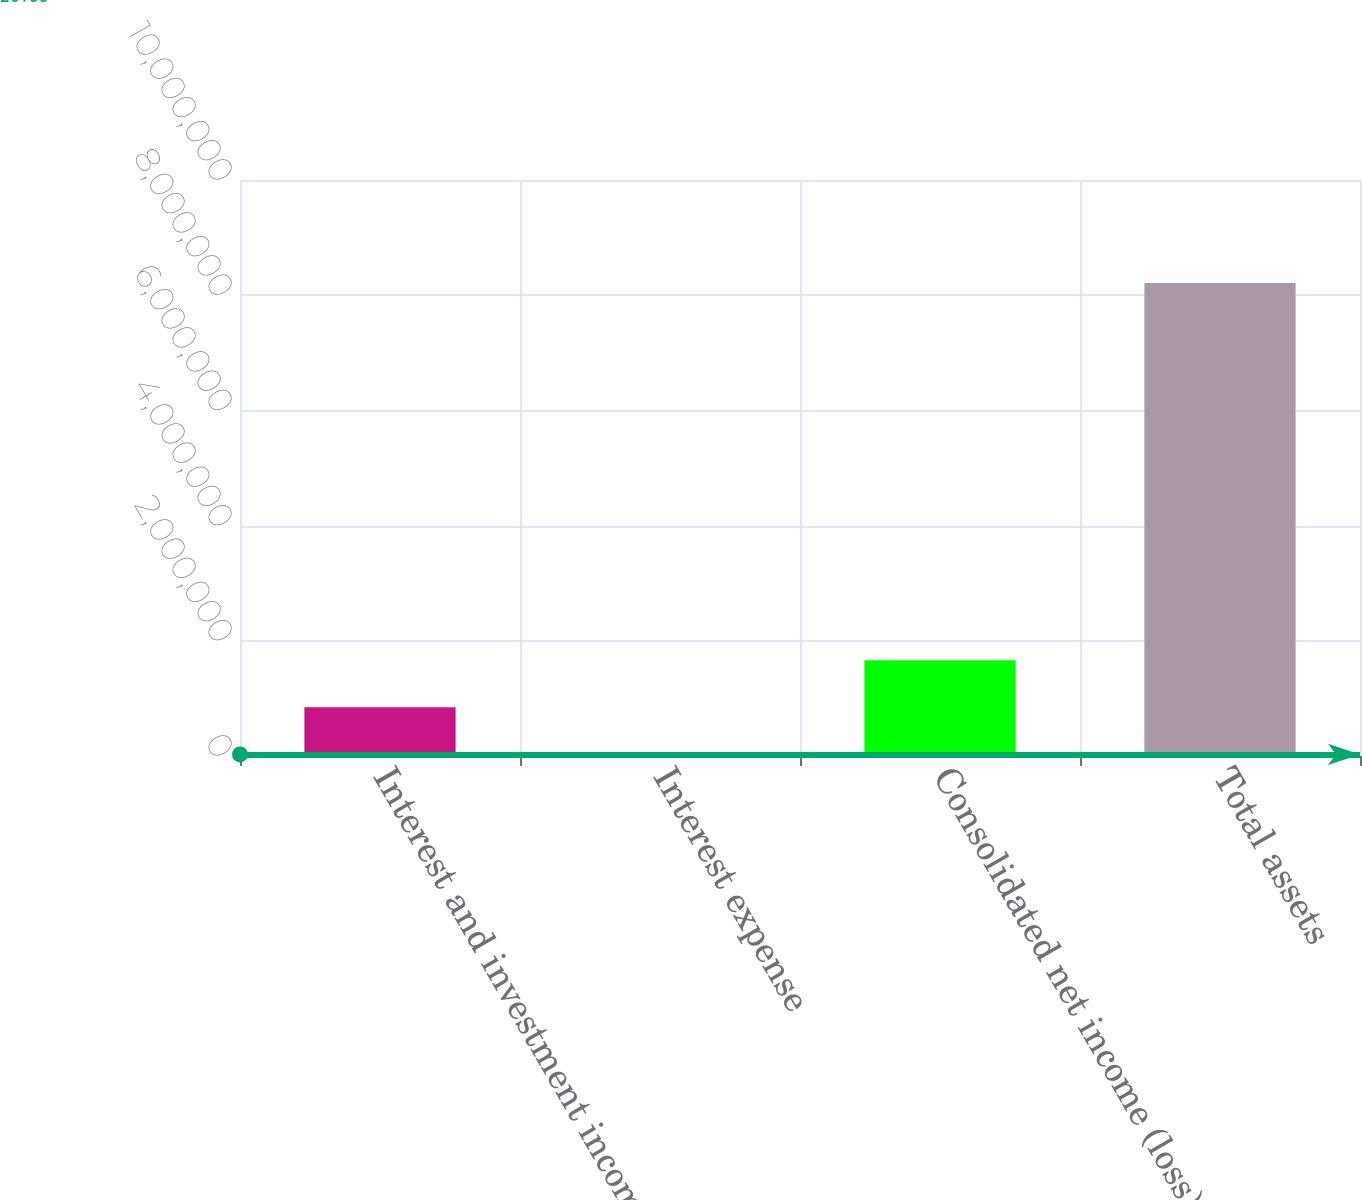Convert chart. <chart><loc_0><loc_0><loc_500><loc_500><bar_chart><fcel>Interest and investment income<fcel>Interest expense<fcel>Consolidated net income (loss)<fcel>Total assets<nl><fcel>845128<fcel>26788<fcel>1.66347e+06<fcel>8.21018e+06<nl></chart> 